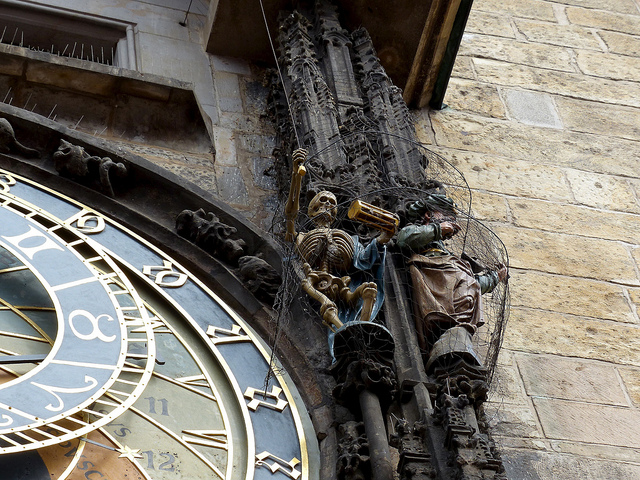Please transcribe the text in this image. ZO N ZZ OC 11 23 12 SVS II 19 